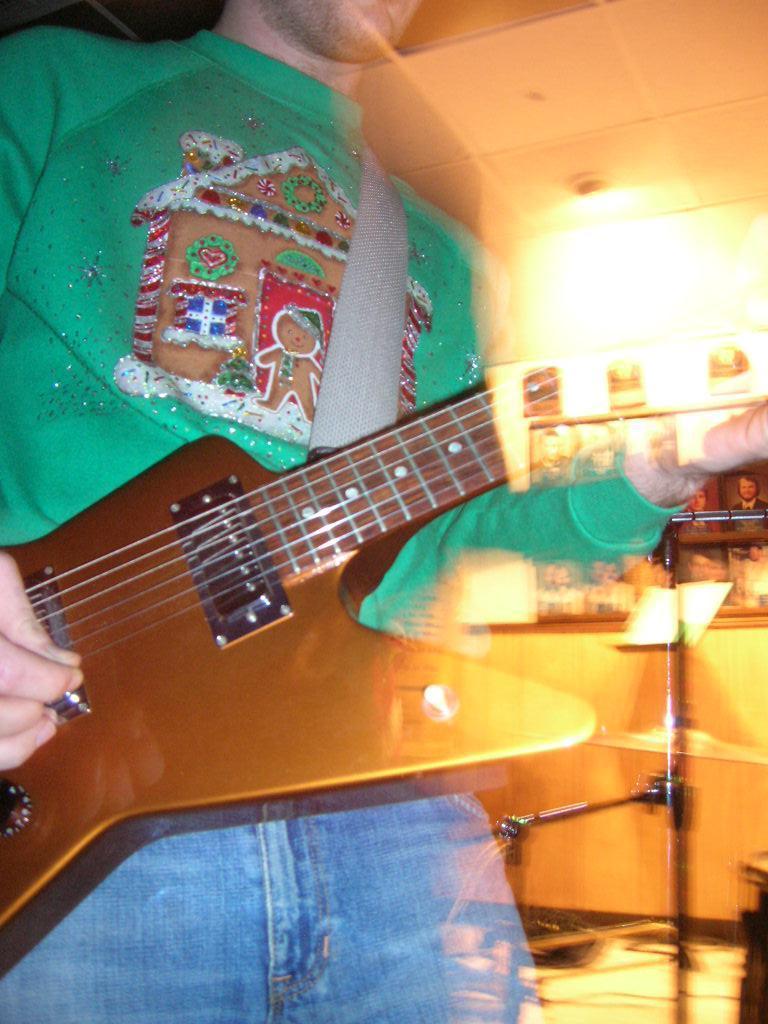Can you describe this image briefly? In this image we can see a person holding a musical instrument and we can also see the lights. 